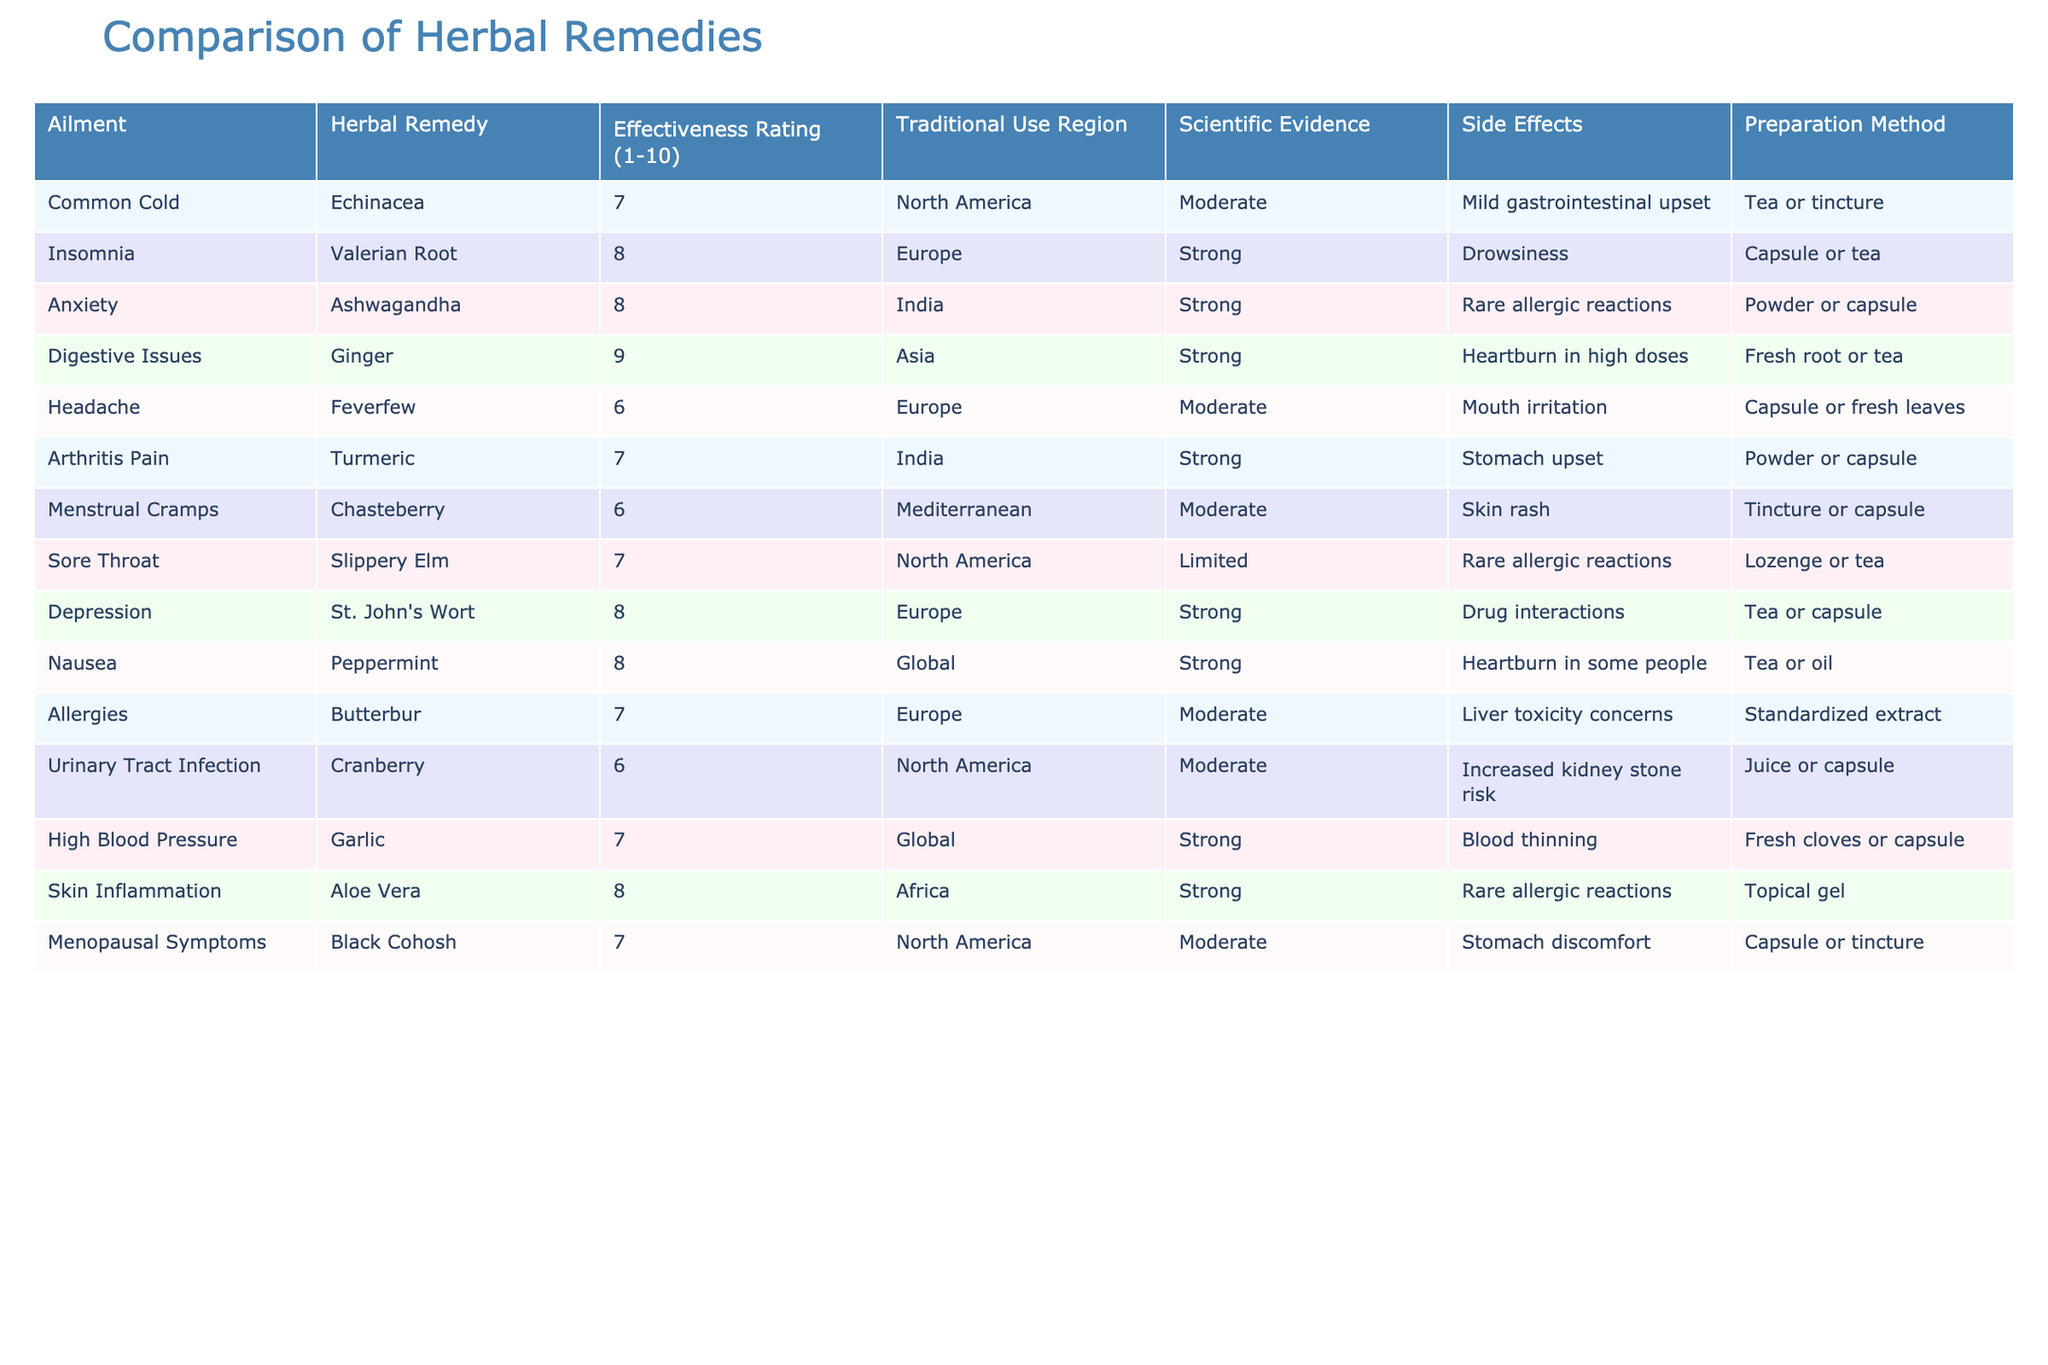What is the effectiveness rating of Echinacea for the common cold? The table lists the effectiveness rating of Echinacea specifically for the common cold, which is given as a 7.
Answer: 7 Which herbal remedy has the highest effectiveness rating for digestive issues? According to the table, Ginger has the highest effectiveness rating of 9 for digestive issues.
Answer: 9 Is there any herbal remedy with a documented strong scientific evidence for treating anxiety? The table indicates that Ashwagandha has strong scientific evidence for treating anxiety, thus confirming the fact.
Answer: Yes What is the average effectiveness rating of the herbal remedies listed for menstrual cramps and urinary tract infections? The effectiveness rating for Menstrual Cramps (Chasteberry) is 6, and for Urinary Tract Infection (Cranberry) is also 6. The average is calculated as (6 + 6) / 2 = 6.
Answer: 6 Is the preparation method for Aloe Vera intended for internal or external use? The table specifies that Aloe Vera is prepared as a topical gel, indicating that it is for external use.
Answer: External use What is the side effect associated with the highest effectiveness rated herbal remedy? The remedy with the highest effectiveness rating is Ginger (9), which has a side effect of heartburn in high doses.
Answer: Heartburn in high doses Which herbal remedy has a moderate rating for effectiveness yet has strong scientific evidence? Turmeric has a moderate effectiveness rating of 7, but it also has strong scientific evidence according to the table.
Answer: Turmeric What is the effectiveness rating difference between Valerian Root and St. John’s Wort? Valerian Root has an effectiveness rating of 8, while St. John's Wort also has a rating of 8. The difference is calculated as 8 - 8 = 0.
Answer: 0 